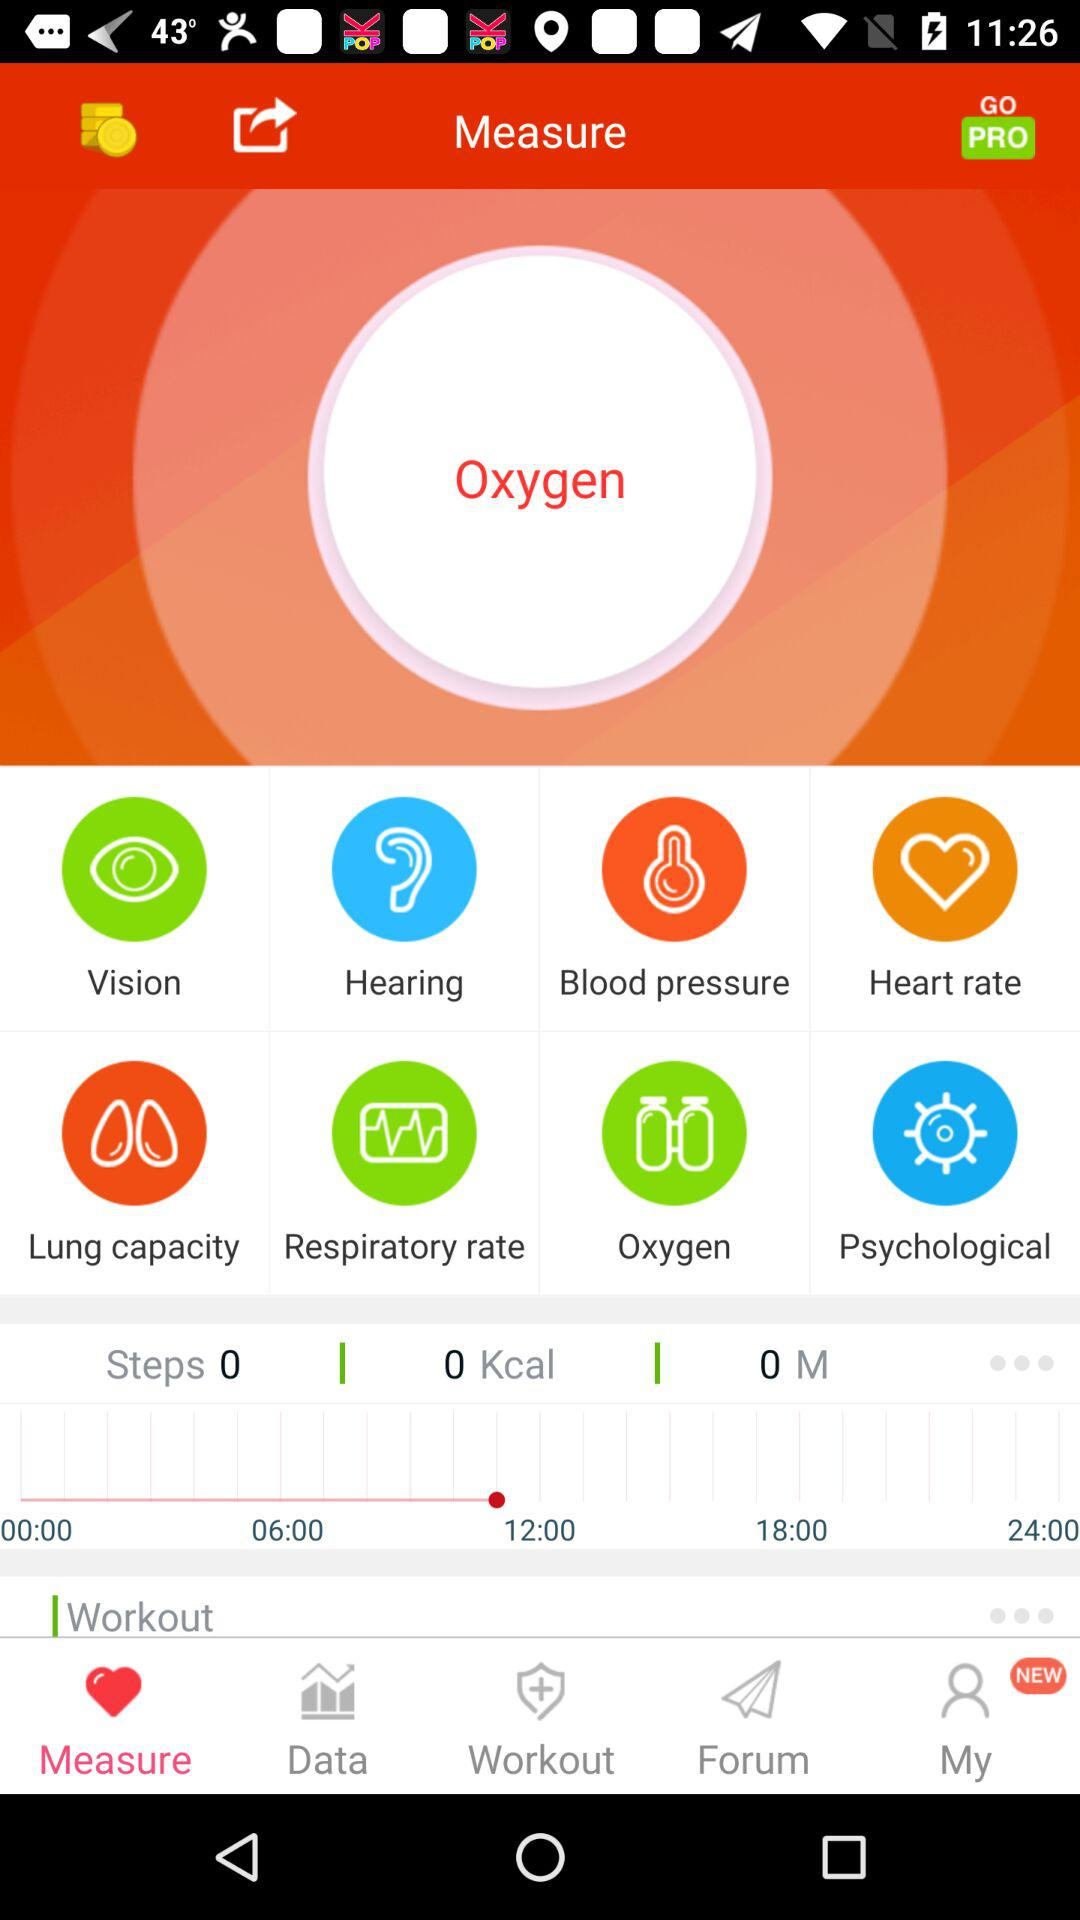What tab is selected? The selected tab is "Measure". 